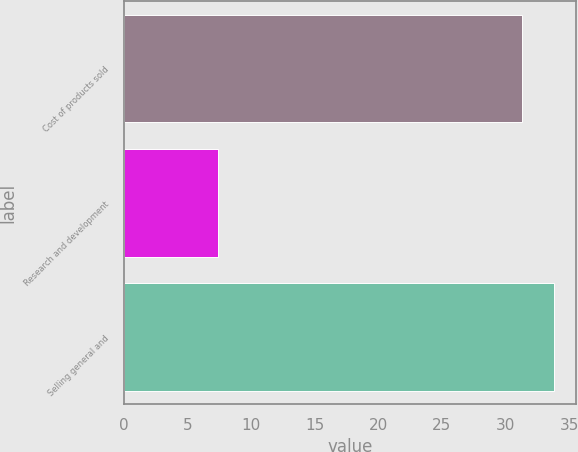Convert chart to OTSL. <chart><loc_0><loc_0><loc_500><loc_500><bar_chart><fcel>Cost of products sold<fcel>Research and development<fcel>Selling general and<nl><fcel>31.3<fcel>7.4<fcel>33.83<nl></chart> 